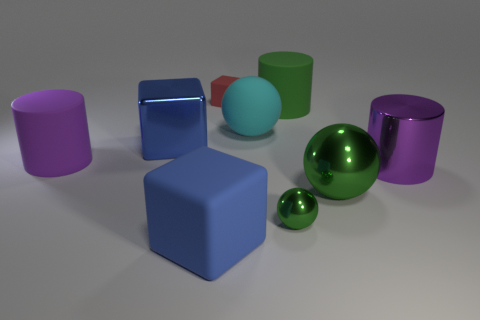What is the cyan thing made of?
Ensure brevity in your answer.  Rubber. What color is the cylinder that is left of the tiny rubber object?
Your answer should be very brief. Purple. Is the number of small metal spheres behind the tiny rubber cube greater than the number of large green things on the left side of the large cyan sphere?
Provide a short and direct response. No. What is the size of the cylinder left of the blue object to the right of the large blue thing behind the large purple matte cylinder?
Make the answer very short. Large. Are there any other cubes that have the same color as the big matte block?
Your answer should be compact. Yes. How many big yellow matte balls are there?
Give a very brief answer. 0. The large blue cube behind the large sphere that is to the right of the small thing that is in front of the big purple metal cylinder is made of what material?
Your response must be concise. Metal. Are there any green cylinders made of the same material as the large cyan ball?
Your response must be concise. Yes. Does the cyan ball have the same material as the small green thing?
Provide a succinct answer. No. How many cylinders are large purple matte things or tiny things?
Offer a terse response. 1. 